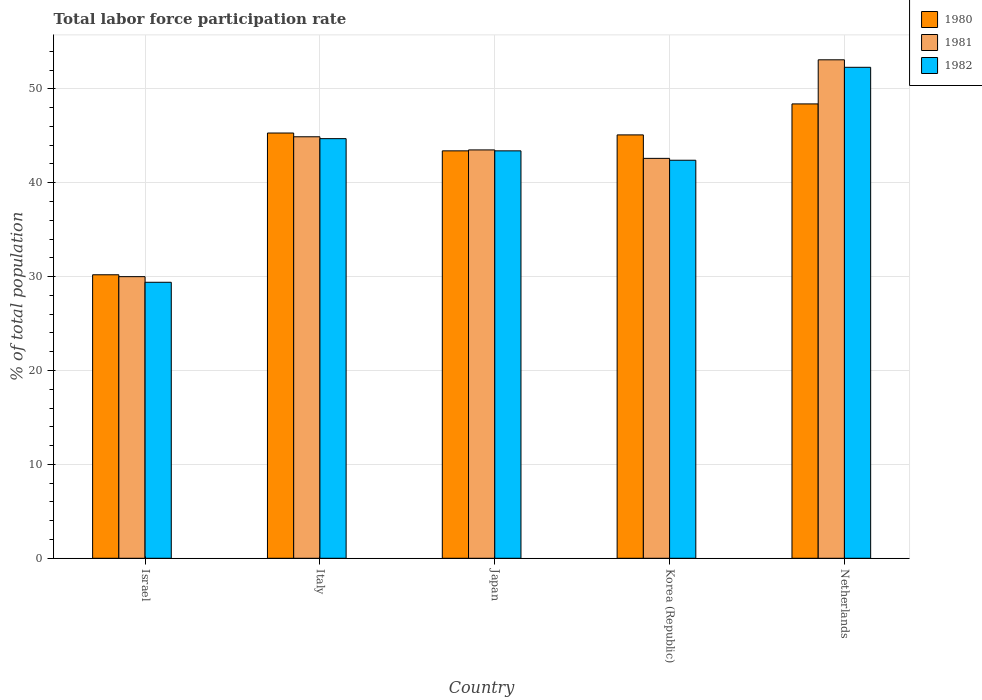What is the total labor force participation rate in 1981 in Netherlands?
Your response must be concise. 53.1. Across all countries, what is the maximum total labor force participation rate in 1981?
Offer a terse response. 53.1. Across all countries, what is the minimum total labor force participation rate in 1982?
Offer a very short reply. 29.4. In which country was the total labor force participation rate in 1981 minimum?
Your answer should be very brief. Israel. What is the total total labor force participation rate in 1981 in the graph?
Your answer should be compact. 214.1. What is the difference between the total labor force participation rate in 1982 in Israel and that in Korea (Republic)?
Ensure brevity in your answer.  -13. What is the difference between the total labor force participation rate in 1982 in Italy and the total labor force participation rate in 1981 in Korea (Republic)?
Your answer should be very brief. 2.1. What is the average total labor force participation rate in 1980 per country?
Provide a succinct answer. 42.48. What is the difference between the total labor force participation rate of/in 1982 and total labor force participation rate of/in 1981 in Korea (Republic)?
Your answer should be compact. -0.2. In how many countries, is the total labor force participation rate in 1980 greater than 52 %?
Your answer should be compact. 0. What is the ratio of the total labor force participation rate in 1980 in Italy to that in Japan?
Your answer should be compact. 1.04. What is the difference between the highest and the second highest total labor force participation rate in 1982?
Provide a succinct answer. -8.9. What is the difference between the highest and the lowest total labor force participation rate in 1981?
Make the answer very short. 23.1. How many bars are there?
Provide a short and direct response. 15. Are all the bars in the graph horizontal?
Provide a succinct answer. No. What is the difference between two consecutive major ticks on the Y-axis?
Offer a very short reply. 10. Does the graph contain any zero values?
Keep it short and to the point. No. Does the graph contain grids?
Provide a succinct answer. Yes. How many legend labels are there?
Offer a very short reply. 3. What is the title of the graph?
Give a very brief answer. Total labor force participation rate. Does "1991" appear as one of the legend labels in the graph?
Your answer should be compact. No. What is the label or title of the Y-axis?
Give a very brief answer. % of total population. What is the % of total population of 1980 in Israel?
Offer a terse response. 30.2. What is the % of total population of 1981 in Israel?
Your answer should be very brief. 30. What is the % of total population of 1982 in Israel?
Offer a very short reply. 29.4. What is the % of total population in 1980 in Italy?
Give a very brief answer. 45.3. What is the % of total population of 1981 in Italy?
Offer a very short reply. 44.9. What is the % of total population in 1982 in Italy?
Keep it short and to the point. 44.7. What is the % of total population of 1980 in Japan?
Make the answer very short. 43.4. What is the % of total population of 1981 in Japan?
Provide a short and direct response. 43.5. What is the % of total population of 1982 in Japan?
Keep it short and to the point. 43.4. What is the % of total population of 1980 in Korea (Republic)?
Your answer should be compact. 45.1. What is the % of total population of 1981 in Korea (Republic)?
Offer a very short reply. 42.6. What is the % of total population in 1982 in Korea (Republic)?
Offer a terse response. 42.4. What is the % of total population in 1980 in Netherlands?
Your answer should be compact. 48.4. What is the % of total population in 1981 in Netherlands?
Your answer should be very brief. 53.1. What is the % of total population of 1982 in Netherlands?
Provide a short and direct response. 52.3. Across all countries, what is the maximum % of total population of 1980?
Make the answer very short. 48.4. Across all countries, what is the maximum % of total population of 1981?
Make the answer very short. 53.1. Across all countries, what is the maximum % of total population of 1982?
Offer a terse response. 52.3. Across all countries, what is the minimum % of total population of 1980?
Your response must be concise. 30.2. Across all countries, what is the minimum % of total population in 1982?
Your answer should be compact. 29.4. What is the total % of total population in 1980 in the graph?
Offer a terse response. 212.4. What is the total % of total population in 1981 in the graph?
Provide a short and direct response. 214.1. What is the total % of total population of 1982 in the graph?
Your answer should be compact. 212.2. What is the difference between the % of total population of 1980 in Israel and that in Italy?
Keep it short and to the point. -15.1. What is the difference between the % of total population in 1981 in Israel and that in Italy?
Make the answer very short. -14.9. What is the difference between the % of total population of 1982 in Israel and that in Italy?
Provide a short and direct response. -15.3. What is the difference between the % of total population in 1981 in Israel and that in Japan?
Offer a terse response. -13.5. What is the difference between the % of total population in 1982 in Israel and that in Japan?
Your answer should be very brief. -14. What is the difference between the % of total population of 1980 in Israel and that in Korea (Republic)?
Your response must be concise. -14.9. What is the difference between the % of total population of 1981 in Israel and that in Korea (Republic)?
Provide a short and direct response. -12.6. What is the difference between the % of total population of 1980 in Israel and that in Netherlands?
Make the answer very short. -18.2. What is the difference between the % of total population in 1981 in Israel and that in Netherlands?
Your answer should be compact. -23.1. What is the difference between the % of total population in 1982 in Israel and that in Netherlands?
Your answer should be very brief. -22.9. What is the difference between the % of total population of 1981 in Italy and that in Japan?
Your response must be concise. 1.4. What is the difference between the % of total population of 1982 in Italy and that in Korea (Republic)?
Give a very brief answer. 2.3. What is the difference between the % of total population of 1982 in Italy and that in Netherlands?
Keep it short and to the point. -7.6. What is the difference between the % of total population in 1980 in Japan and that in Netherlands?
Provide a short and direct response. -5. What is the difference between the % of total population of 1981 in Japan and that in Netherlands?
Provide a short and direct response. -9.6. What is the difference between the % of total population of 1980 in Israel and the % of total population of 1981 in Italy?
Provide a succinct answer. -14.7. What is the difference between the % of total population of 1980 in Israel and the % of total population of 1982 in Italy?
Offer a terse response. -14.5. What is the difference between the % of total population in 1981 in Israel and the % of total population in 1982 in Italy?
Provide a succinct answer. -14.7. What is the difference between the % of total population in 1980 in Israel and the % of total population in 1981 in Japan?
Provide a short and direct response. -13.3. What is the difference between the % of total population in 1981 in Israel and the % of total population in 1982 in Japan?
Ensure brevity in your answer.  -13.4. What is the difference between the % of total population of 1980 in Israel and the % of total population of 1981 in Korea (Republic)?
Provide a short and direct response. -12.4. What is the difference between the % of total population of 1980 in Israel and the % of total population of 1981 in Netherlands?
Make the answer very short. -22.9. What is the difference between the % of total population in 1980 in Israel and the % of total population in 1982 in Netherlands?
Offer a terse response. -22.1. What is the difference between the % of total population in 1981 in Israel and the % of total population in 1982 in Netherlands?
Provide a short and direct response. -22.3. What is the difference between the % of total population of 1981 in Italy and the % of total population of 1982 in Japan?
Offer a very short reply. 1.5. What is the difference between the % of total population of 1980 in Italy and the % of total population of 1981 in Korea (Republic)?
Provide a short and direct response. 2.7. What is the difference between the % of total population of 1980 in Italy and the % of total population of 1981 in Netherlands?
Keep it short and to the point. -7.8. What is the difference between the % of total population in 1980 in Italy and the % of total population in 1982 in Netherlands?
Ensure brevity in your answer.  -7. What is the difference between the % of total population in 1981 in Italy and the % of total population in 1982 in Netherlands?
Keep it short and to the point. -7.4. What is the difference between the % of total population in 1980 in Japan and the % of total population in 1982 in Korea (Republic)?
Provide a succinct answer. 1. What is the difference between the % of total population of 1981 in Japan and the % of total population of 1982 in Korea (Republic)?
Provide a succinct answer. 1.1. What is the difference between the % of total population of 1980 in Japan and the % of total population of 1981 in Netherlands?
Your answer should be compact. -9.7. What is the difference between the % of total population of 1980 in Japan and the % of total population of 1982 in Netherlands?
Your response must be concise. -8.9. What is the difference between the % of total population of 1980 in Korea (Republic) and the % of total population of 1982 in Netherlands?
Offer a terse response. -7.2. What is the average % of total population of 1980 per country?
Keep it short and to the point. 42.48. What is the average % of total population in 1981 per country?
Give a very brief answer. 42.82. What is the average % of total population of 1982 per country?
Keep it short and to the point. 42.44. What is the difference between the % of total population of 1980 and % of total population of 1981 in Israel?
Your answer should be compact. 0.2. What is the difference between the % of total population in 1980 and % of total population in 1982 in Israel?
Provide a short and direct response. 0.8. What is the difference between the % of total population in 1981 and % of total population in 1982 in Israel?
Offer a very short reply. 0.6. What is the difference between the % of total population of 1980 and % of total population of 1981 in Japan?
Give a very brief answer. -0.1. What is the difference between the % of total population of 1980 and % of total population of 1981 in Korea (Republic)?
Your answer should be very brief. 2.5. What is the difference between the % of total population of 1980 and % of total population of 1982 in Korea (Republic)?
Offer a terse response. 2.7. What is the difference between the % of total population in 1980 and % of total population in 1981 in Netherlands?
Make the answer very short. -4.7. What is the difference between the % of total population of 1981 and % of total population of 1982 in Netherlands?
Offer a very short reply. 0.8. What is the ratio of the % of total population of 1980 in Israel to that in Italy?
Provide a succinct answer. 0.67. What is the ratio of the % of total population in 1981 in Israel to that in Italy?
Provide a succinct answer. 0.67. What is the ratio of the % of total population of 1982 in Israel to that in Italy?
Your answer should be compact. 0.66. What is the ratio of the % of total population in 1980 in Israel to that in Japan?
Ensure brevity in your answer.  0.7. What is the ratio of the % of total population of 1981 in Israel to that in Japan?
Offer a terse response. 0.69. What is the ratio of the % of total population in 1982 in Israel to that in Japan?
Make the answer very short. 0.68. What is the ratio of the % of total population of 1980 in Israel to that in Korea (Republic)?
Make the answer very short. 0.67. What is the ratio of the % of total population of 1981 in Israel to that in Korea (Republic)?
Ensure brevity in your answer.  0.7. What is the ratio of the % of total population of 1982 in Israel to that in Korea (Republic)?
Your answer should be very brief. 0.69. What is the ratio of the % of total population of 1980 in Israel to that in Netherlands?
Your answer should be very brief. 0.62. What is the ratio of the % of total population of 1981 in Israel to that in Netherlands?
Your answer should be very brief. 0.56. What is the ratio of the % of total population of 1982 in Israel to that in Netherlands?
Give a very brief answer. 0.56. What is the ratio of the % of total population in 1980 in Italy to that in Japan?
Ensure brevity in your answer.  1.04. What is the ratio of the % of total population in 1981 in Italy to that in Japan?
Provide a succinct answer. 1.03. What is the ratio of the % of total population of 1980 in Italy to that in Korea (Republic)?
Provide a short and direct response. 1. What is the ratio of the % of total population of 1981 in Italy to that in Korea (Republic)?
Your answer should be compact. 1.05. What is the ratio of the % of total population of 1982 in Italy to that in Korea (Republic)?
Make the answer very short. 1.05. What is the ratio of the % of total population of 1980 in Italy to that in Netherlands?
Your answer should be compact. 0.94. What is the ratio of the % of total population of 1981 in Italy to that in Netherlands?
Your response must be concise. 0.85. What is the ratio of the % of total population in 1982 in Italy to that in Netherlands?
Offer a terse response. 0.85. What is the ratio of the % of total population in 1980 in Japan to that in Korea (Republic)?
Ensure brevity in your answer.  0.96. What is the ratio of the % of total population in 1981 in Japan to that in Korea (Republic)?
Provide a short and direct response. 1.02. What is the ratio of the % of total population in 1982 in Japan to that in Korea (Republic)?
Offer a terse response. 1.02. What is the ratio of the % of total population of 1980 in Japan to that in Netherlands?
Offer a very short reply. 0.9. What is the ratio of the % of total population of 1981 in Japan to that in Netherlands?
Provide a succinct answer. 0.82. What is the ratio of the % of total population of 1982 in Japan to that in Netherlands?
Ensure brevity in your answer.  0.83. What is the ratio of the % of total population in 1980 in Korea (Republic) to that in Netherlands?
Ensure brevity in your answer.  0.93. What is the ratio of the % of total population of 1981 in Korea (Republic) to that in Netherlands?
Offer a very short reply. 0.8. What is the ratio of the % of total population in 1982 in Korea (Republic) to that in Netherlands?
Offer a very short reply. 0.81. What is the difference between the highest and the second highest % of total population in 1982?
Offer a very short reply. 7.6. What is the difference between the highest and the lowest % of total population in 1980?
Ensure brevity in your answer.  18.2. What is the difference between the highest and the lowest % of total population in 1981?
Keep it short and to the point. 23.1. What is the difference between the highest and the lowest % of total population of 1982?
Provide a short and direct response. 22.9. 